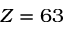Convert formula to latex. <formula><loc_0><loc_0><loc_500><loc_500>Z = 6 3</formula> 